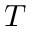Convert formula to latex. <formula><loc_0><loc_0><loc_500><loc_500>T</formula> 